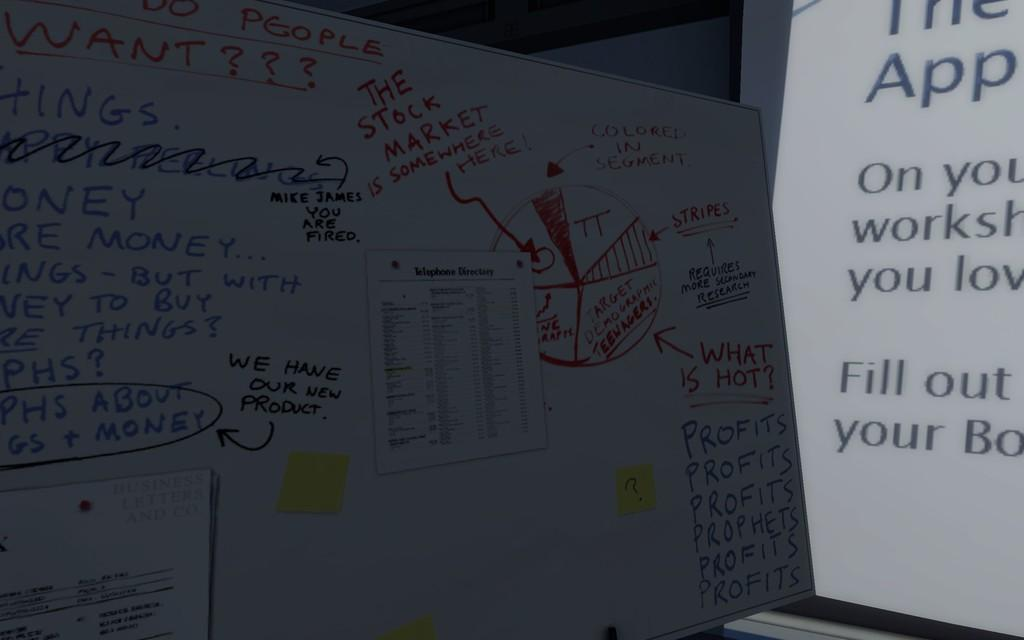<image>
Describe the image concisely. A white board seems to show writings from a brainstorming session concerning a product and the stock market. 